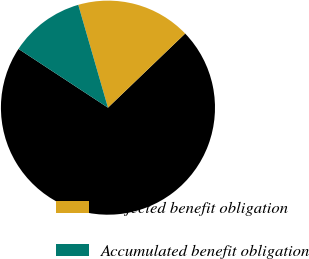Convert chart. <chart><loc_0><loc_0><loc_500><loc_500><pie_chart><fcel>(in millions)<fcel>Projected benefit obligation<fcel>Accumulated benefit obligation<nl><fcel>71.42%<fcel>17.3%<fcel>11.28%<nl></chart> 